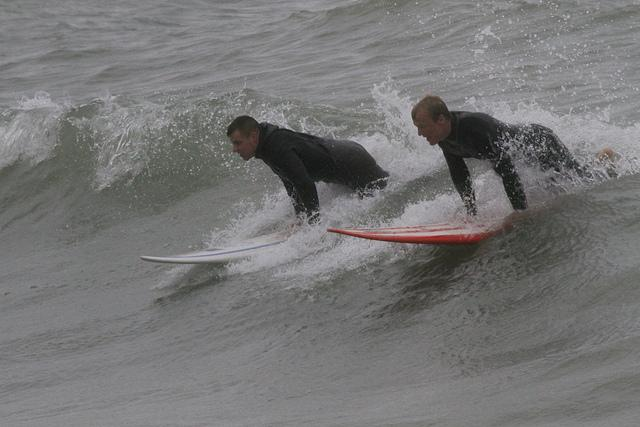What are the men on the boards attempting to do?

Choices:
A) stand
B) lay
C) dive
D) jump stand 